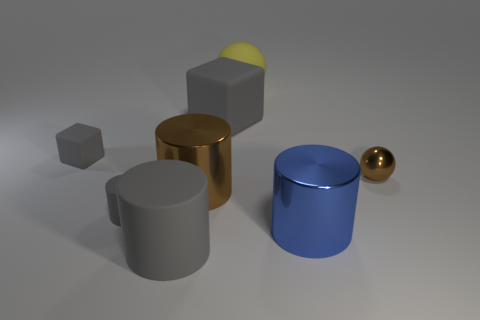Are there any other things that have the same size as the brown sphere?
Your answer should be compact. Yes. There is a cube in front of the big cube; what is its size?
Provide a short and direct response. Small. Is there a small gray cube made of the same material as the small gray cylinder?
Ensure brevity in your answer.  Yes. There is a large rubber object that is behind the large matte cube; does it have the same color as the shiny sphere?
Your response must be concise. No. Is the number of things that are in front of the brown metallic ball the same as the number of gray matte objects?
Give a very brief answer. Yes. Is there a small object that has the same color as the small cube?
Your response must be concise. Yes. Do the shiny ball and the blue metallic cylinder have the same size?
Your response must be concise. No. What is the size of the sphere left of the brown metallic object that is to the right of the yellow ball?
Offer a terse response. Large. There is a rubber thing that is to the right of the tiny gray matte cylinder and in front of the small cube; what size is it?
Ensure brevity in your answer.  Large. How many other blue cylinders are the same size as the blue cylinder?
Provide a short and direct response. 0. 